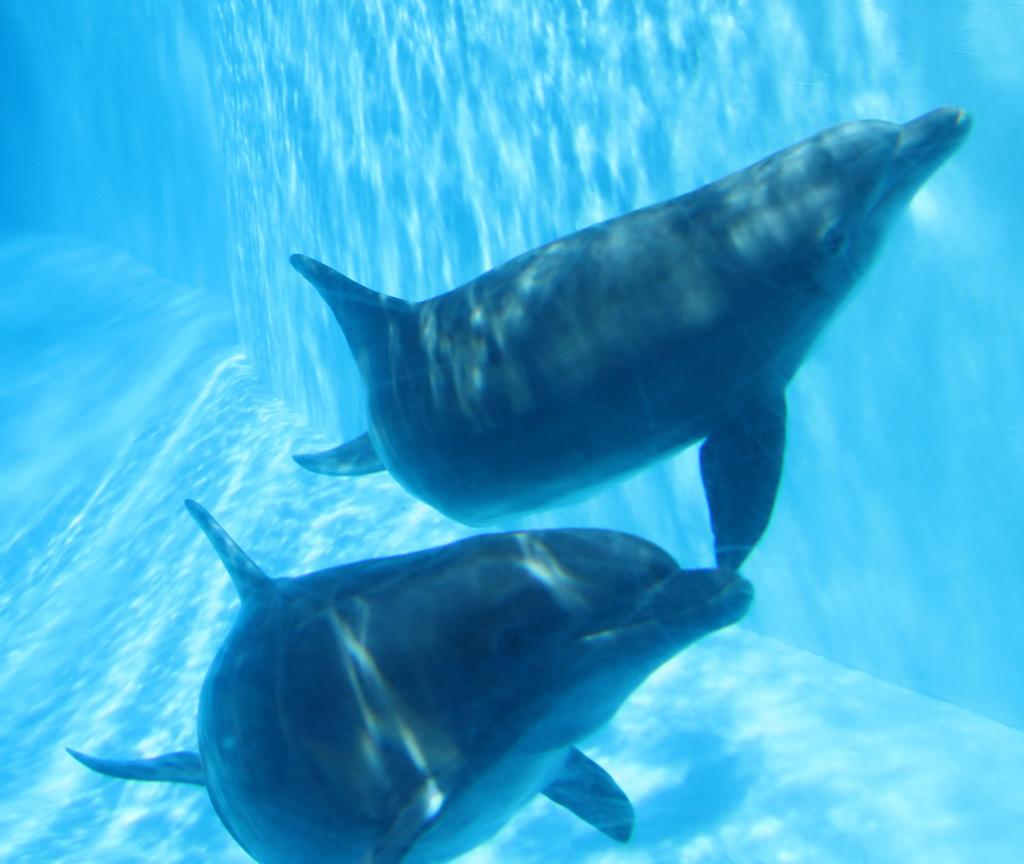What type of animals can be seen in the image? There are aquatic animals in the image. Where are the aquatic animals located? The aquatic animals are in the water. What type of jail can be seen in the image? There is no jail present in the image; it features aquatic animals in the water. What type of exchange is happening between the aquatic animals in the image? There is no exchange happening between the aquatic animals in the image; they are simply in the water. 